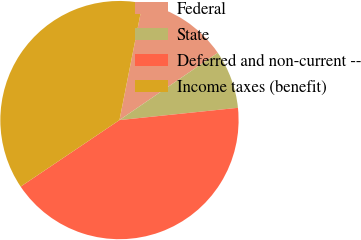<chart> <loc_0><loc_0><loc_500><loc_500><pie_chart><fcel>Federal<fcel>State<fcel>Deferred and non-current --<fcel>Income taxes (benefit)<nl><fcel>12.34%<fcel>7.91%<fcel>42.21%<fcel>37.54%<nl></chart> 